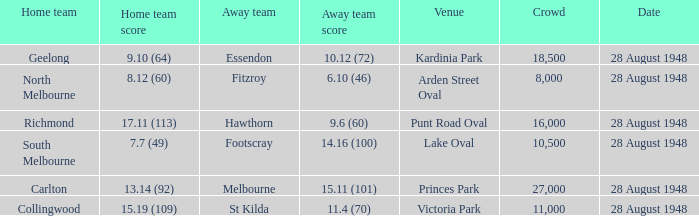What home team has a team score of 8.12 (60)? North Melbourne. 